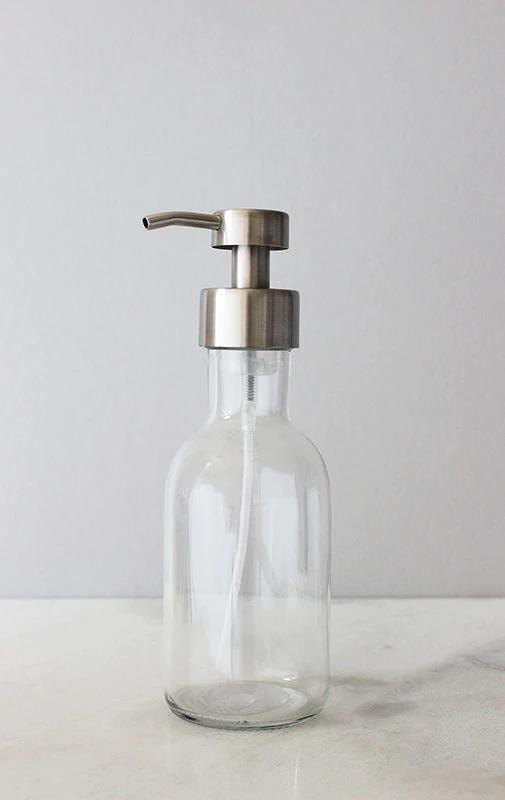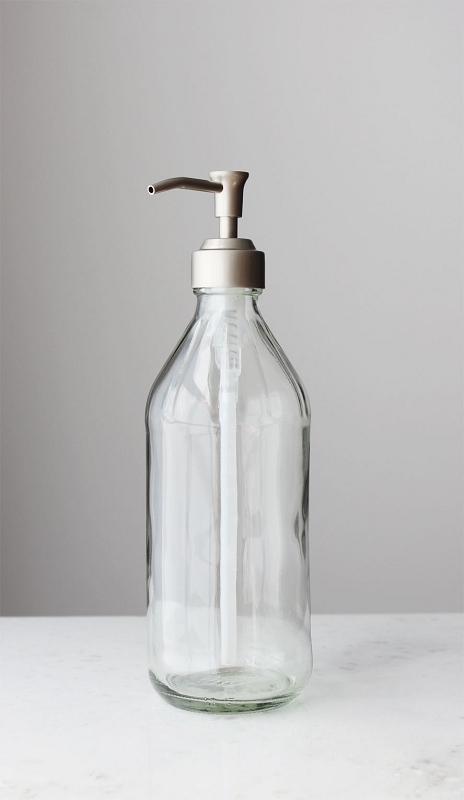The first image is the image on the left, the second image is the image on the right. Considering the images on both sides, is "The left image features a caddy that holds two dispenser bottles side-by-side, and their pump nozzles face right." valid? Answer yes or no. No. The first image is the image on the left, the second image is the image on the right. Evaluate the accuracy of this statement regarding the images: "There are exactly two clear dispensers, one in each image.". Is it true? Answer yes or no. Yes. 